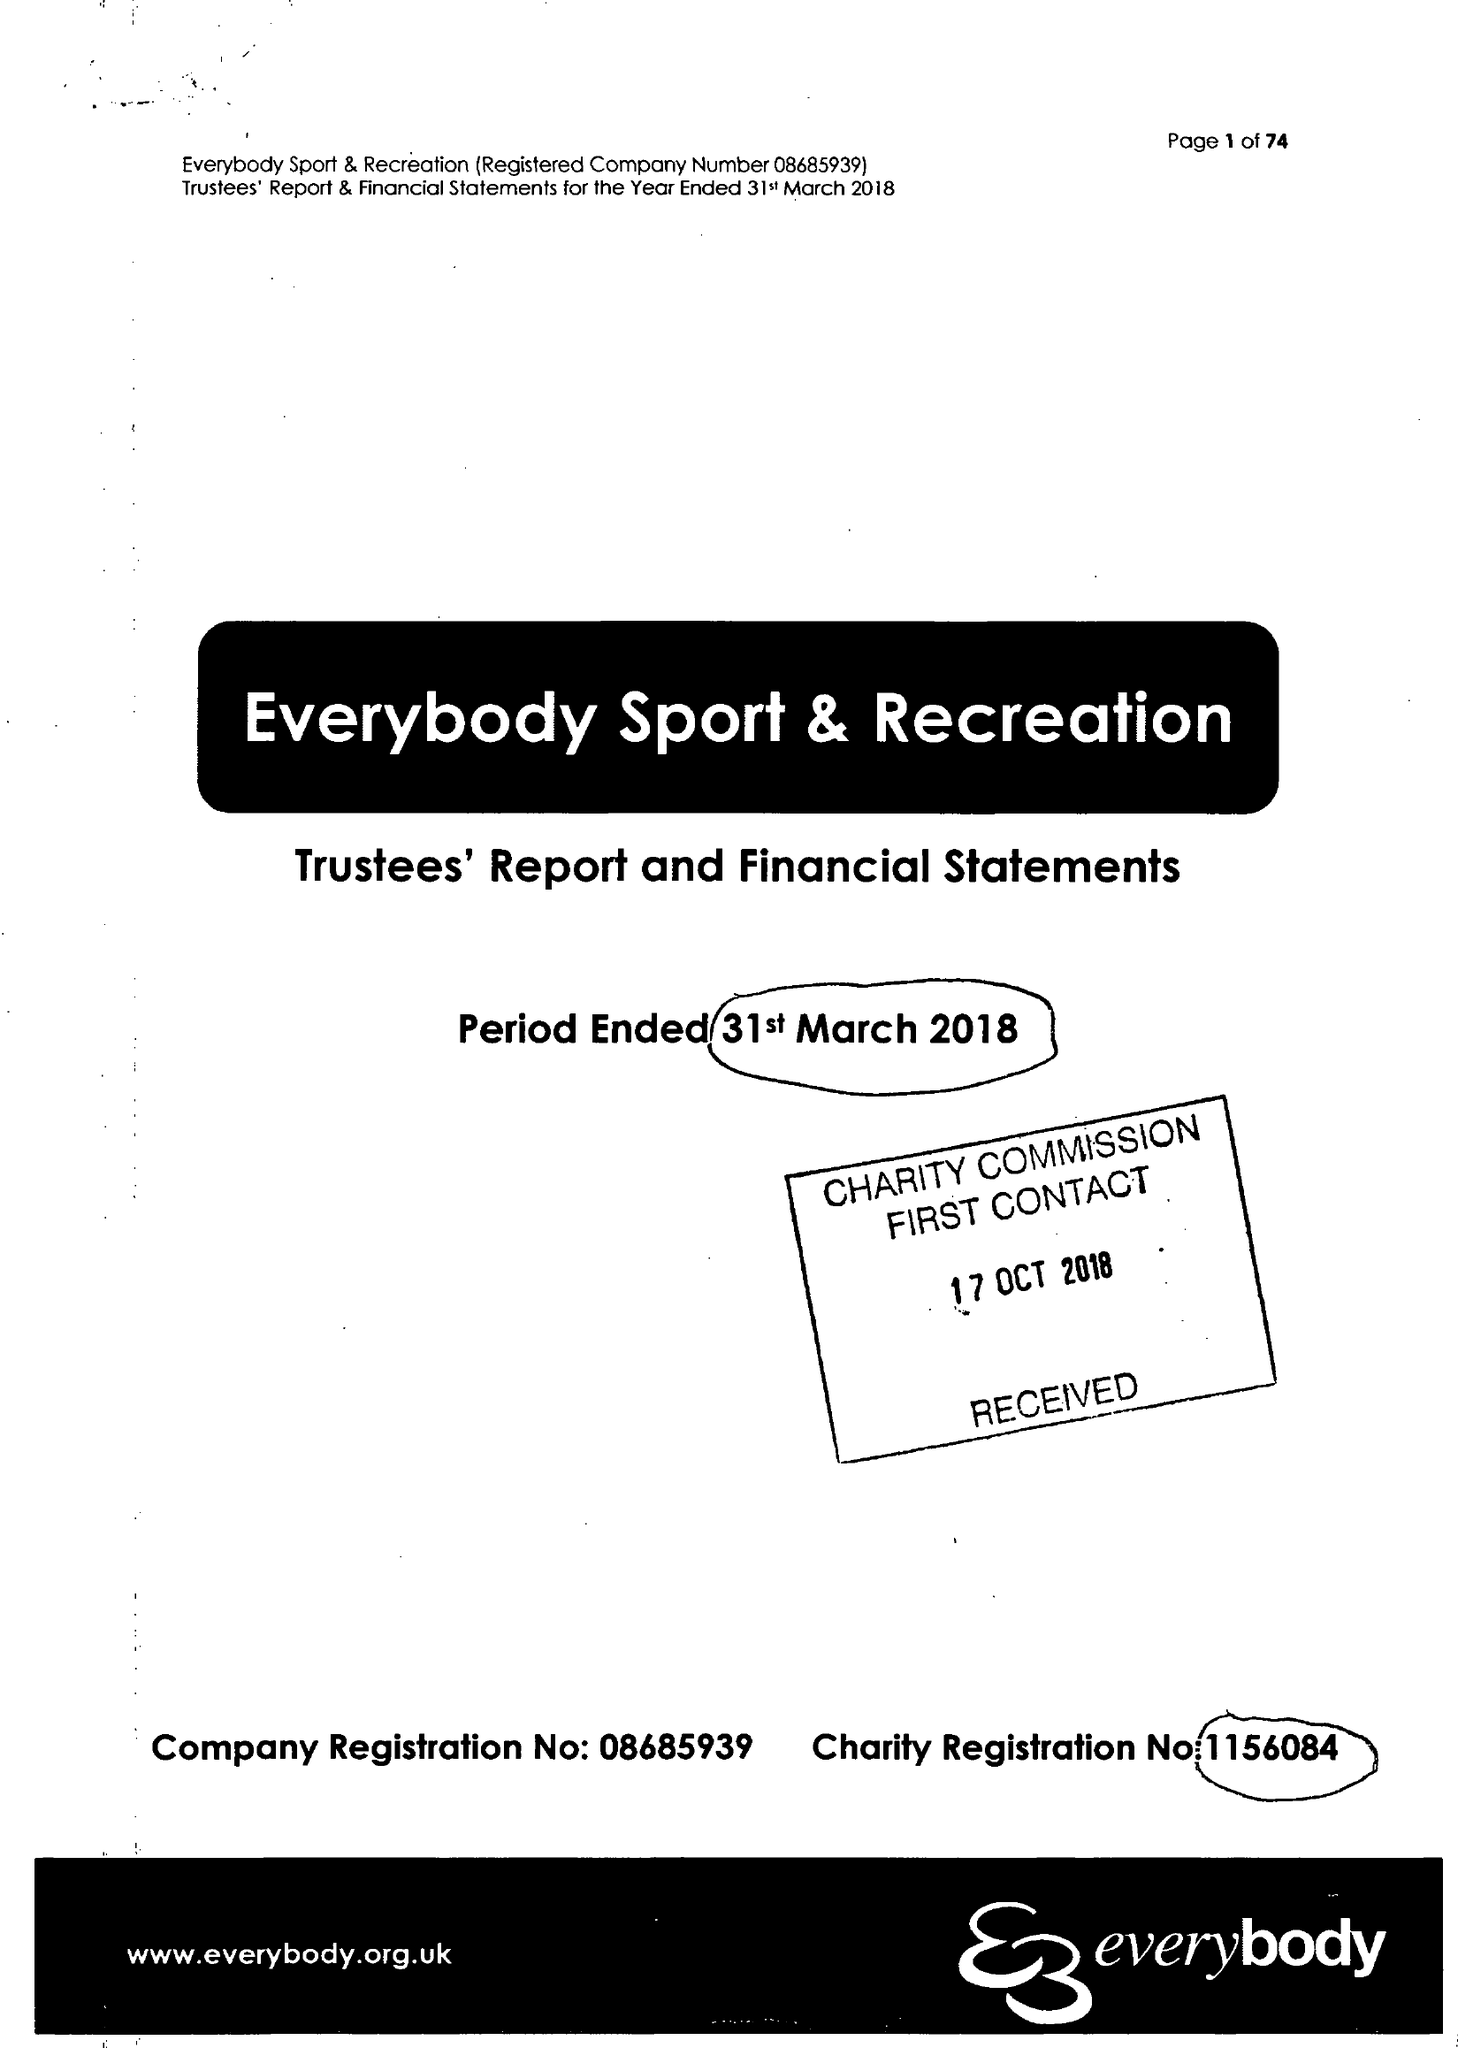What is the value for the address__postcode?
Answer the question using a single word or phrase. CW4 8AA 